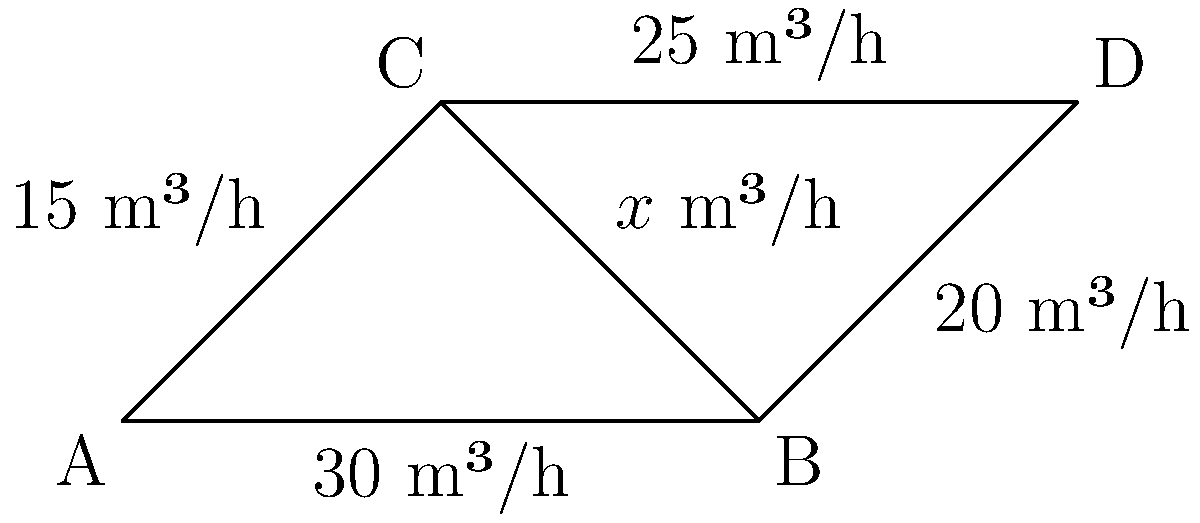In your biogas pipeline network, the flow rates (in m³/h) are shown on each pipe. Determine the value of $x$ to ensure conservation of mass at each node. What is the flow rate in the pipe connecting nodes B and C? To solve this problem, we'll use the principle of conservation of mass at each node. This means that the total flow entering a node must equal the total flow leaving the node.

Step 1: Analyze node A
- Inflow: 0 m³/h
- Outflow: 30 m³/h + 15 m³/h = 45 m³/h
- Net outflow from A: 45 m³/h

Step 2: Analyze node B
- Inflow: 30 m³/h
- Outflow: 20 m³/h + $x$ m³/h
- For conservation: 30 = 20 + $x$

Step 3: Solve for $x$
$x = 30 - 20 = 10$ m³/h

Step 4: Verify conservation at node C
- Inflow: 15 m³/h + 10 m³/h = 25 m³/h
- Outflow: 25 m³/h
- Conservation is satisfied

Step 5: Verify conservation at node D
- Inflow: 20 m³/h + 25 m³/h = 45 m³/h
- Outflow: 45 m³/h (to maintain overall system balance)
- Conservation is satisfied

Therefore, the flow rate in the pipe connecting nodes B and C is 10 m³/h.
Answer: 10 m³/h 